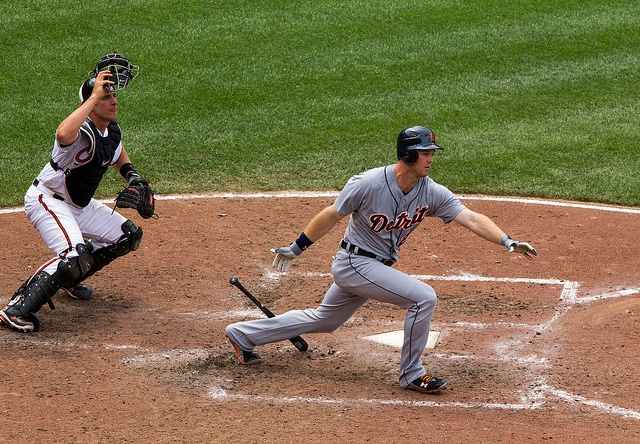Describe the objects in this image and their specific colors. I can see people in darkgreen, gray, black, and darkgray tones, people in darkgreen, black, lavender, gray, and darkgray tones, baseball glove in darkgreen, black, gray, and maroon tones, and baseball bat in darkgreen, black, gray, and tan tones in this image. 